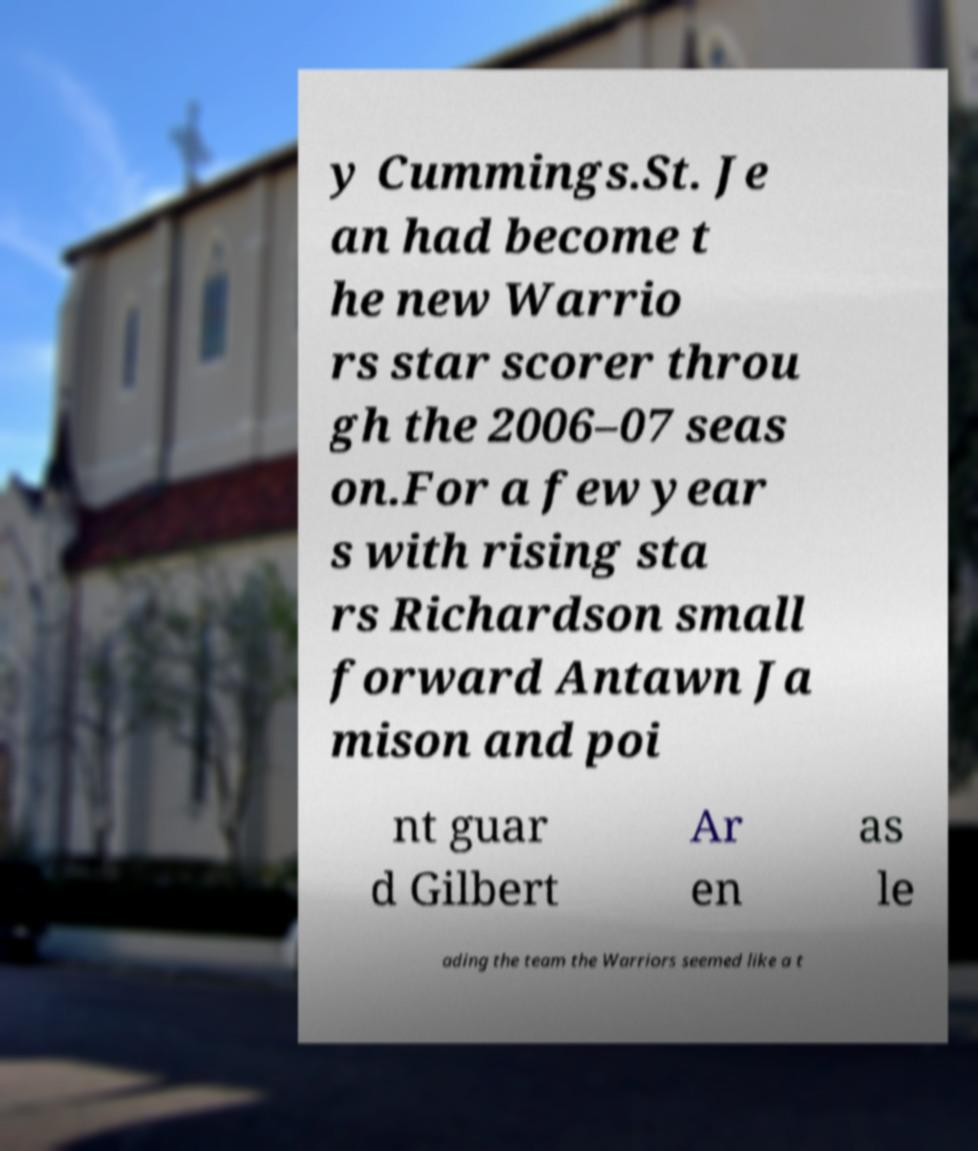What messages or text are displayed in this image? I need them in a readable, typed format. y Cummings.St. Je an had become t he new Warrio rs star scorer throu gh the 2006–07 seas on.For a few year s with rising sta rs Richardson small forward Antawn Ja mison and poi nt guar d Gilbert Ar en as le ading the team the Warriors seemed like a t 